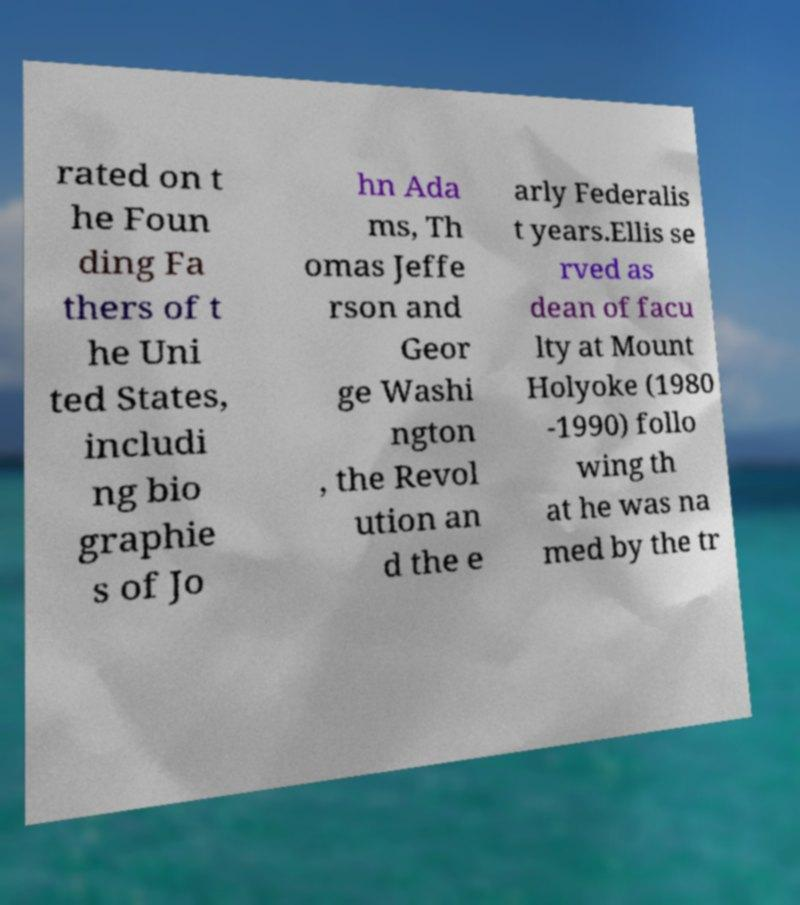Can you read and provide the text displayed in the image?This photo seems to have some interesting text. Can you extract and type it out for me? rated on t he Foun ding Fa thers of t he Uni ted States, includi ng bio graphie s of Jo hn Ada ms, Th omas Jeffe rson and Geor ge Washi ngton , the Revol ution an d the e arly Federalis t years.Ellis se rved as dean of facu lty at Mount Holyoke (1980 -1990) follo wing th at he was na med by the tr 